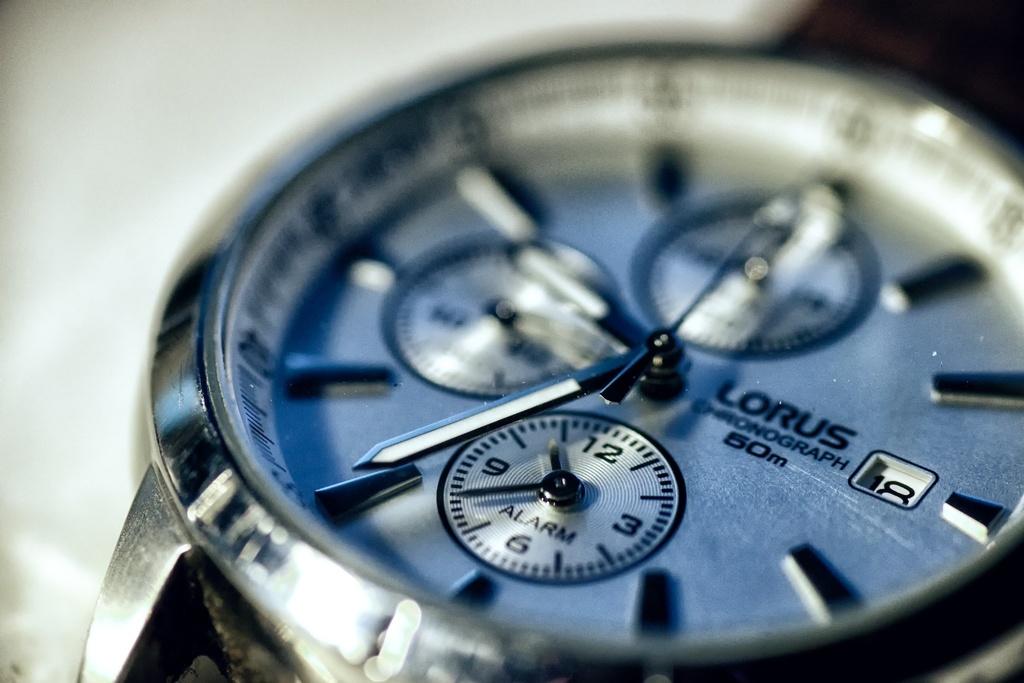What brand of watch is this?
Keep it short and to the point. Lorus. What brand is this watch?
Give a very brief answer. Lorus. 